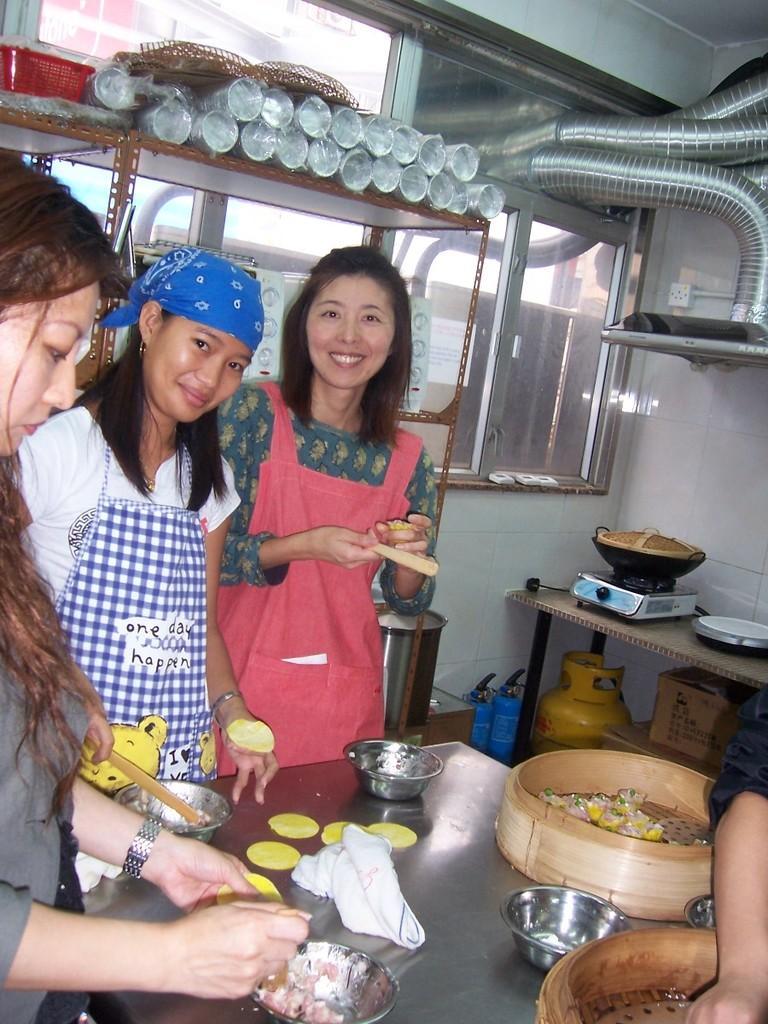In one or two sentences, can you explain what this image depicts? In this image, I can see three women standing. At the bottom of the image, I can see a table with bowls, cloth and few other things on it. On the right side of the image, I can see another table with a stove, pan and few other things. I can see few objects under the table. It looks like a person's hand. At the top of the image, I can see few object, which are placed in a rack. In the background, I think this is a window with the glass doors. It looks like a chimney with the pipes. 